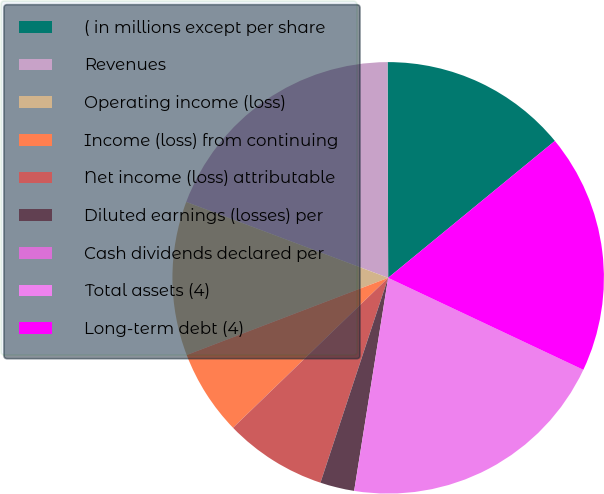Convert chart. <chart><loc_0><loc_0><loc_500><loc_500><pie_chart><fcel>( in millions except per share<fcel>Revenues<fcel>Operating income (loss)<fcel>Income (loss) from continuing<fcel>Net income (loss) attributable<fcel>Diluted earnings (losses) per<fcel>Cash dividends declared per<fcel>Total assets (4)<fcel>Long-term debt (4)<nl><fcel>14.1%<fcel>19.23%<fcel>11.54%<fcel>6.41%<fcel>7.69%<fcel>2.56%<fcel>0.0%<fcel>20.51%<fcel>17.95%<nl></chart> 